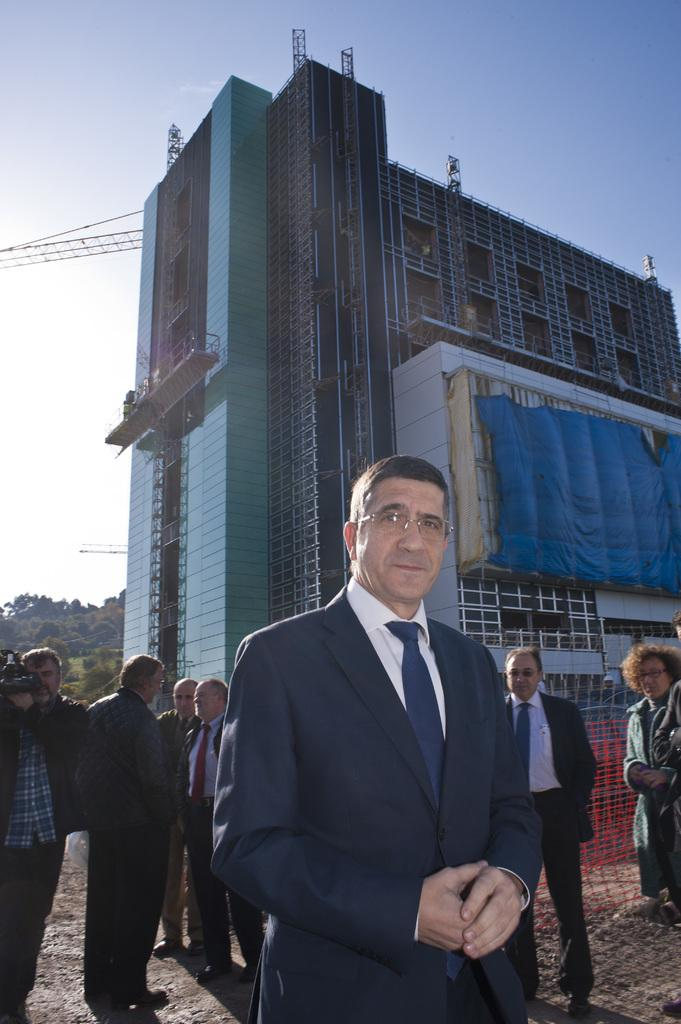What is happening on the ground in the image? There are people on the ground in the image. What can be seen in the background of the image? There is a building and trees in the background of the image. What is visible in the sky in the image? The sky is visible in the background of the image. What type of toothbrush is the beast using in the image? There is no toothbrush or beast present in the image. How does the string connect the people on the ground in the image? There is no string connecting the people on the ground in the image. 